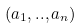<formula> <loc_0><loc_0><loc_500><loc_500>( a _ { 1 } , . . , a _ { n } )</formula> 